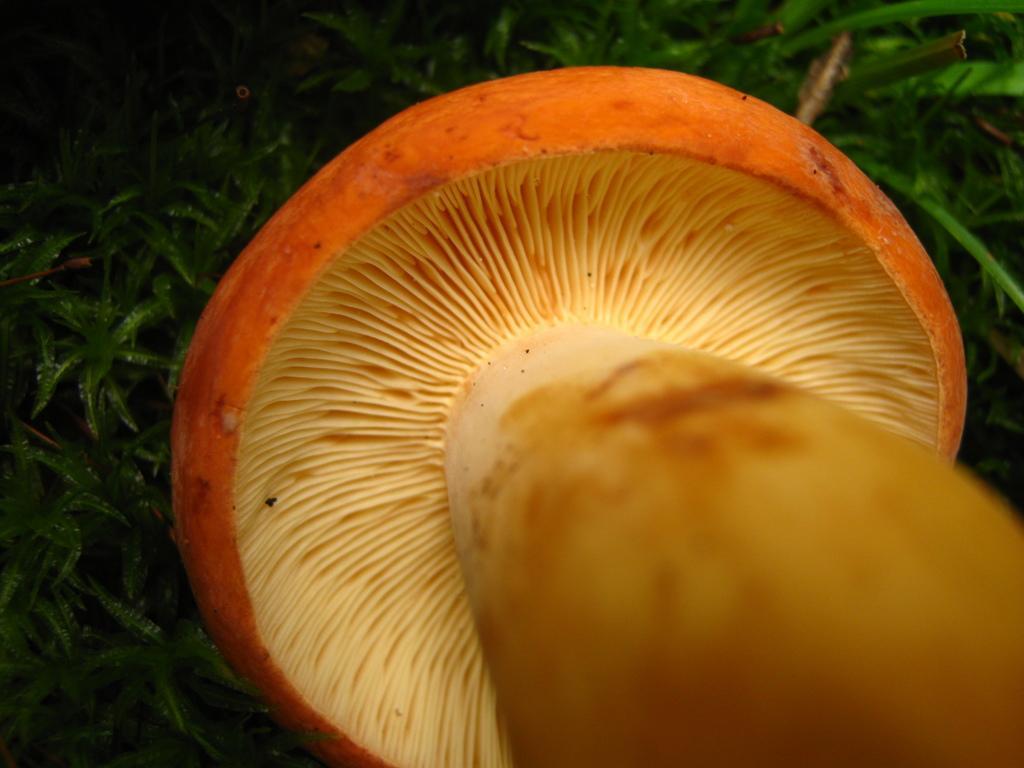How would you summarize this image in a sentence or two? Here in this picture we can see a mushroom present over there and behind it we can see plant present all over there. 